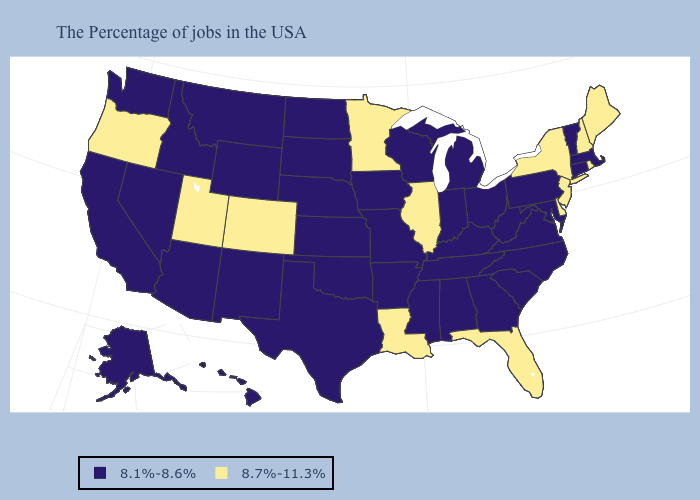Name the states that have a value in the range 8.7%-11.3%?
Write a very short answer. Maine, Rhode Island, New Hampshire, New York, New Jersey, Delaware, Florida, Illinois, Louisiana, Minnesota, Colorado, Utah, Oregon. Name the states that have a value in the range 8.1%-8.6%?
Give a very brief answer. Massachusetts, Vermont, Connecticut, Maryland, Pennsylvania, Virginia, North Carolina, South Carolina, West Virginia, Ohio, Georgia, Michigan, Kentucky, Indiana, Alabama, Tennessee, Wisconsin, Mississippi, Missouri, Arkansas, Iowa, Kansas, Nebraska, Oklahoma, Texas, South Dakota, North Dakota, Wyoming, New Mexico, Montana, Arizona, Idaho, Nevada, California, Washington, Alaska, Hawaii. Which states have the lowest value in the Northeast?
Give a very brief answer. Massachusetts, Vermont, Connecticut, Pennsylvania. Does Pennsylvania have a higher value than Arizona?
Concise answer only. No. Among the states that border Arkansas , does Louisiana have the highest value?
Short answer required. Yes. Name the states that have a value in the range 8.1%-8.6%?
Short answer required. Massachusetts, Vermont, Connecticut, Maryland, Pennsylvania, Virginia, North Carolina, South Carolina, West Virginia, Ohio, Georgia, Michigan, Kentucky, Indiana, Alabama, Tennessee, Wisconsin, Mississippi, Missouri, Arkansas, Iowa, Kansas, Nebraska, Oklahoma, Texas, South Dakota, North Dakota, Wyoming, New Mexico, Montana, Arizona, Idaho, Nevada, California, Washington, Alaska, Hawaii. Name the states that have a value in the range 8.1%-8.6%?
Give a very brief answer. Massachusetts, Vermont, Connecticut, Maryland, Pennsylvania, Virginia, North Carolina, South Carolina, West Virginia, Ohio, Georgia, Michigan, Kentucky, Indiana, Alabama, Tennessee, Wisconsin, Mississippi, Missouri, Arkansas, Iowa, Kansas, Nebraska, Oklahoma, Texas, South Dakota, North Dakota, Wyoming, New Mexico, Montana, Arizona, Idaho, Nevada, California, Washington, Alaska, Hawaii. Which states have the highest value in the USA?
Quick response, please. Maine, Rhode Island, New Hampshire, New York, New Jersey, Delaware, Florida, Illinois, Louisiana, Minnesota, Colorado, Utah, Oregon. Name the states that have a value in the range 8.7%-11.3%?
Be succinct. Maine, Rhode Island, New Hampshire, New York, New Jersey, Delaware, Florida, Illinois, Louisiana, Minnesota, Colorado, Utah, Oregon. Name the states that have a value in the range 8.1%-8.6%?
Quick response, please. Massachusetts, Vermont, Connecticut, Maryland, Pennsylvania, Virginia, North Carolina, South Carolina, West Virginia, Ohio, Georgia, Michigan, Kentucky, Indiana, Alabama, Tennessee, Wisconsin, Mississippi, Missouri, Arkansas, Iowa, Kansas, Nebraska, Oklahoma, Texas, South Dakota, North Dakota, Wyoming, New Mexico, Montana, Arizona, Idaho, Nevada, California, Washington, Alaska, Hawaii. What is the value of Mississippi?
Answer briefly. 8.1%-8.6%. What is the value of California?
Concise answer only. 8.1%-8.6%. Name the states that have a value in the range 8.1%-8.6%?
Keep it brief. Massachusetts, Vermont, Connecticut, Maryland, Pennsylvania, Virginia, North Carolina, South Carolina, West Virginia, Ohio, Georgia, Michigan, Kentucky, Indiana, Alabama, Tennessee, Wisconsin, Mississippi, Missouri, Arkansas, Iowa, Kansas, Nebraska, Oklahoma, Texas, South Dakota, North Dakota, Wyoming, New Mexico, Montana, Arizona, Idaho, Nevada, California, Washington, Alaska, Hawaii. Name the states that have a value in the range 8.7%-11.3%?
Quick response, please. Maine, Rhode Island, New Hampshire, New York, New Jersey, Delaware, Florida, Illinois, Louisiana, Minnesota, Colorado, Utah, Oregon. What is the value of South Carolina?
Be succinct. 8.1%-8.6%. 